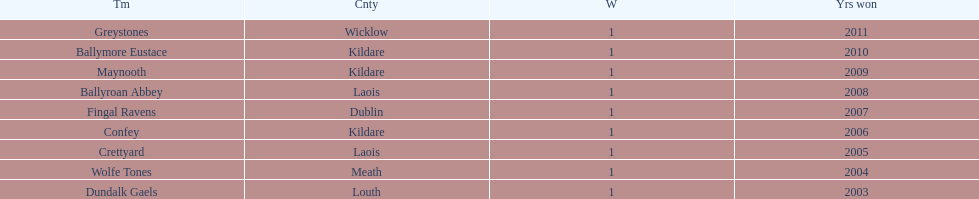Which team was the previous winner before ballyroan abbey in 2008? Fingal Ravens. 